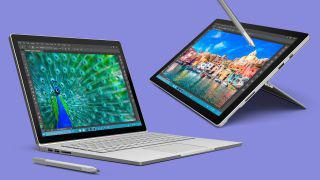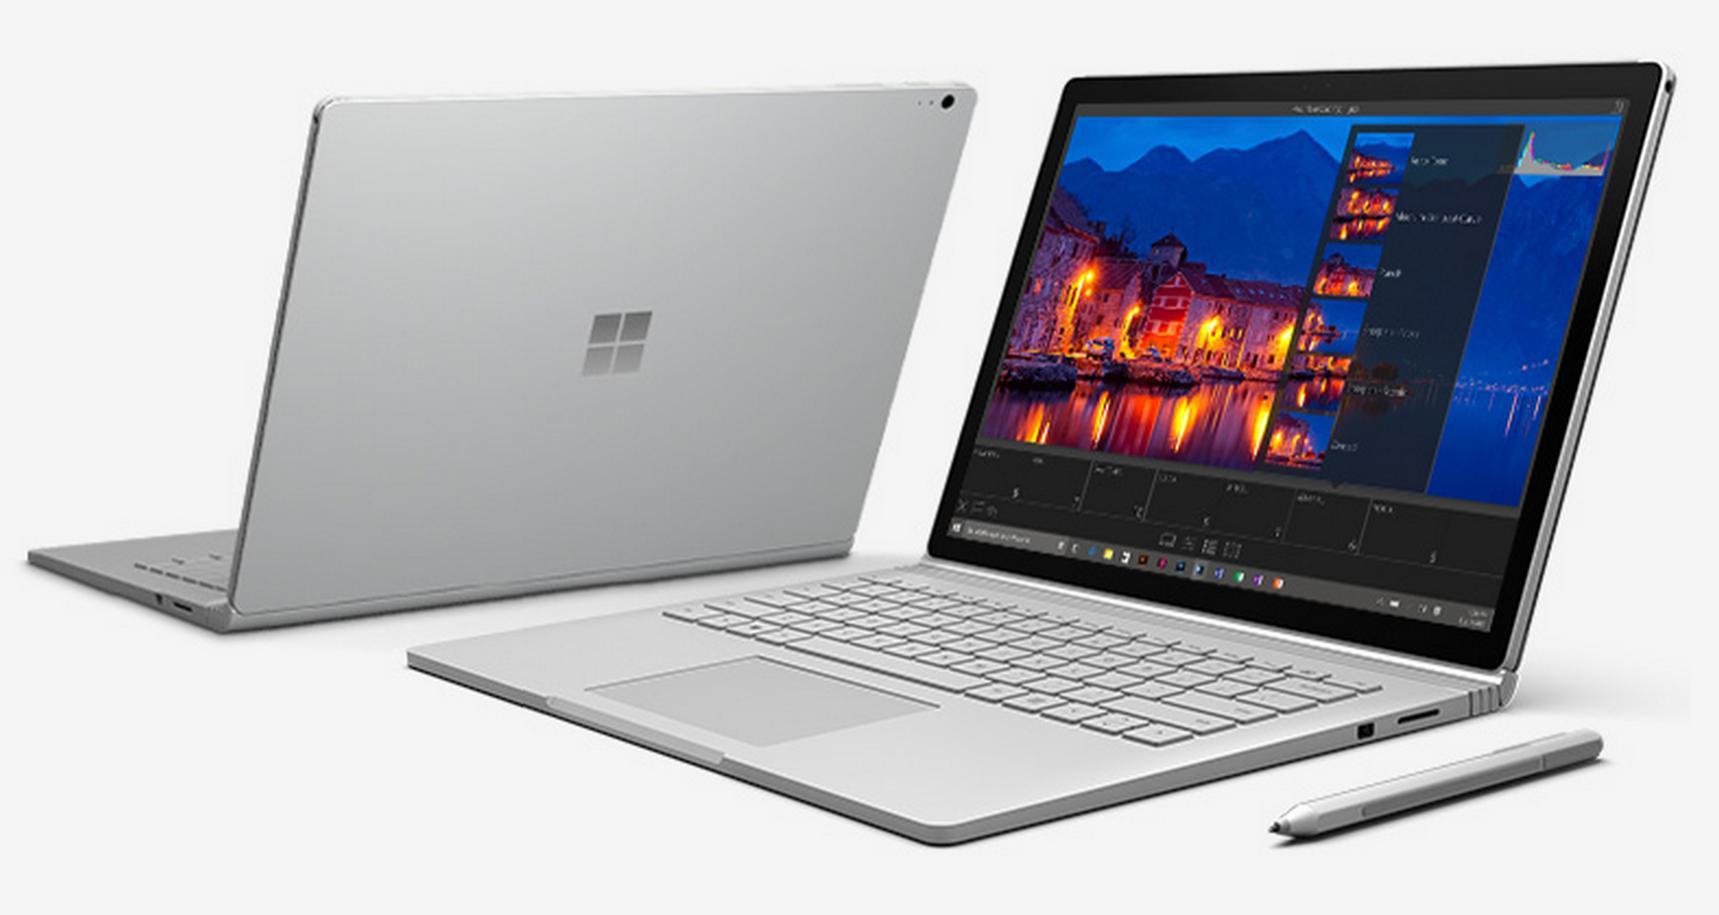The first image is the image on the left, the second image is the image on the right. Assess this claim about the two images: "At least one image contains two open laptops, and the left image includes a laptop with a peacock displayed on its screen.". Correct or not? Answer yes or no. Yes. The first image is the image on the left, the second image is the image on the right. Evaluate the accuracy of this statement regarding the images: "There are two computers". Is it true? Answer yes or no. No. 